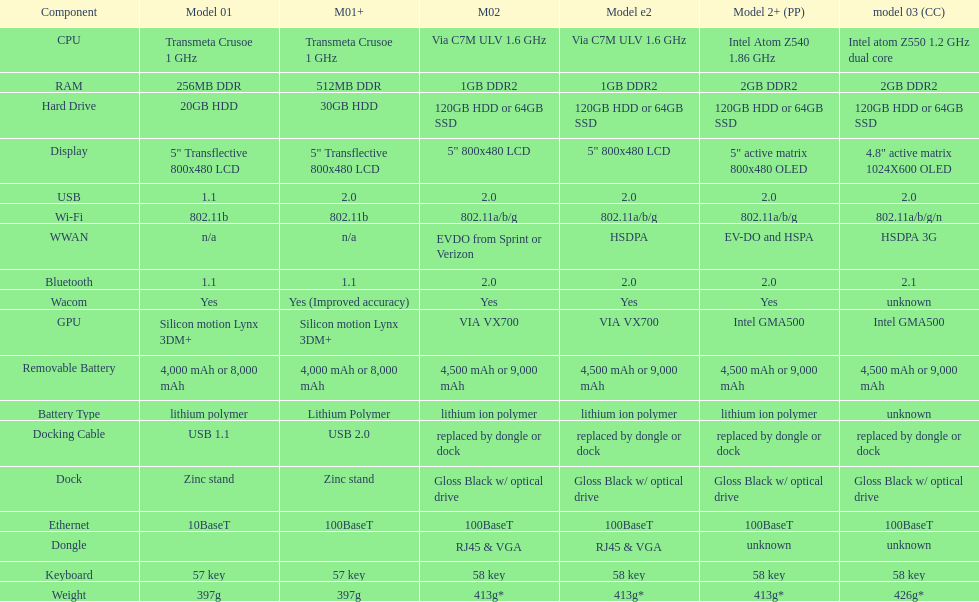What is the total number of components on the chart? 18. 